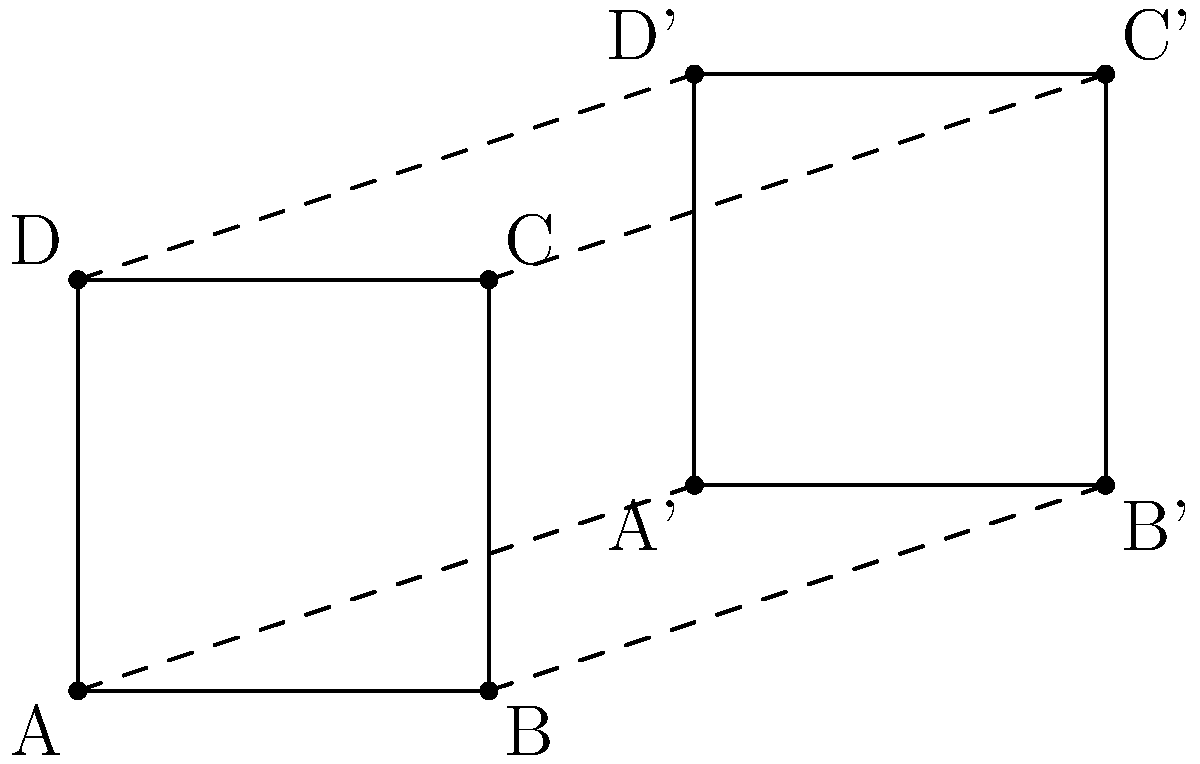Two identical circuit board layouts are shown above, with the second layout (A'B'C'D') being a translated and rotated version of the first (ABCD). If the translation vector is $\vec{v} = (3,1)$, what is the angle of rotation (in degrees) between the two layouts? To find the angle of rotation between the two congruent circuit board layouts, we can follow these steps:

1) First, observe that the translation vector $\vec{v} = (3,1)$ moves point A to A'.

2) If there was only translation and no rotation, all sides of A'B'C'D' would be parallel to the corresponding sides of ABCD.

3) However, we can see that the sides are not parallel, indicating a rotation has occurred.

4) To determine the angle of rotation, we can compare the orientation of any corresponding side. Let's use AB and A'B'.

5) In the original layout, AB is horizontal (parallel to the x-axis).

6) In the transformed layout, A'B' is not horizontal. It makes an angle with the horizontal.

7) This angle is the same as the angle of rotation we're looking for.

8) We can calculate this angle using the arctangent function:
   
   $\theta = \arctan(\frac{y_{B'} - y_{A'}}{x_{B'} - x_{A'}})$

9) From the diagram, we can see that:
   $x_{B'} - x_{A'} = 2$ (the width of the rectangle)
   $y_{B'} - y_{A'} = 0$ (A' and B' are at the same height)

10) Substituting these values:

    $\theta = \arctan(\frac{0}{2}) = 0°$

11) This means there is no rotation between the two layouts.
Answer: 0° 